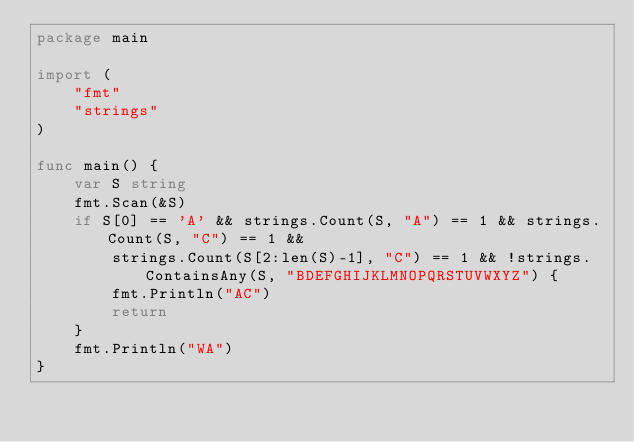Convert code to text. <code><loc_0><loc_0><loc_500><loc_500><_Go_>package main

import (
	"fmt"
	"strings"
)

func main() {
	var S string
	fmt.Scan(&S)
	if S[0] == 'A' && strings.Count(S, "A") == 1 && strings.Count(S, "C") == 1 &&
		strings.Count(S[2:len(S)-1], "C") == 1 && !strings.ContainsAny(S, "BDEFGHIJKLMNOPQRSTUVWXYZ") {
		fmt.Println("AC")
		return
	}
	fmt.Println("WA")
}
</code> 